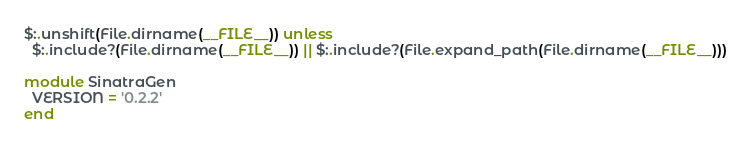<code> <loc_0><loc_0><loc_500><loc_500><_Ruby_>$:.unshift(File.dirname(__FILE__)) unless
  $:.include?(File.dirname(__FILE__)) || $:.include?(File.expand_path(File.dirname(__FILE__)))

module SinatraGen
  VERSION = '0.2.2'
end</code> 